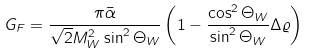<formula> <loc_0><loc_0><loc_500><loc_500>G _ { F } = \frac { \pi \bar { \alpha } } { \sqrt { 2 } M ^ { 2 } _ { W } \sin ^ { 2 } \Theta _ { W } } \left ( 1 - \frac { \cos ^ { 2 } \Theta _ { W } } { \sin ^ { 2 } \Theta _ { W } } \Delta \varrho \right )</formula> 